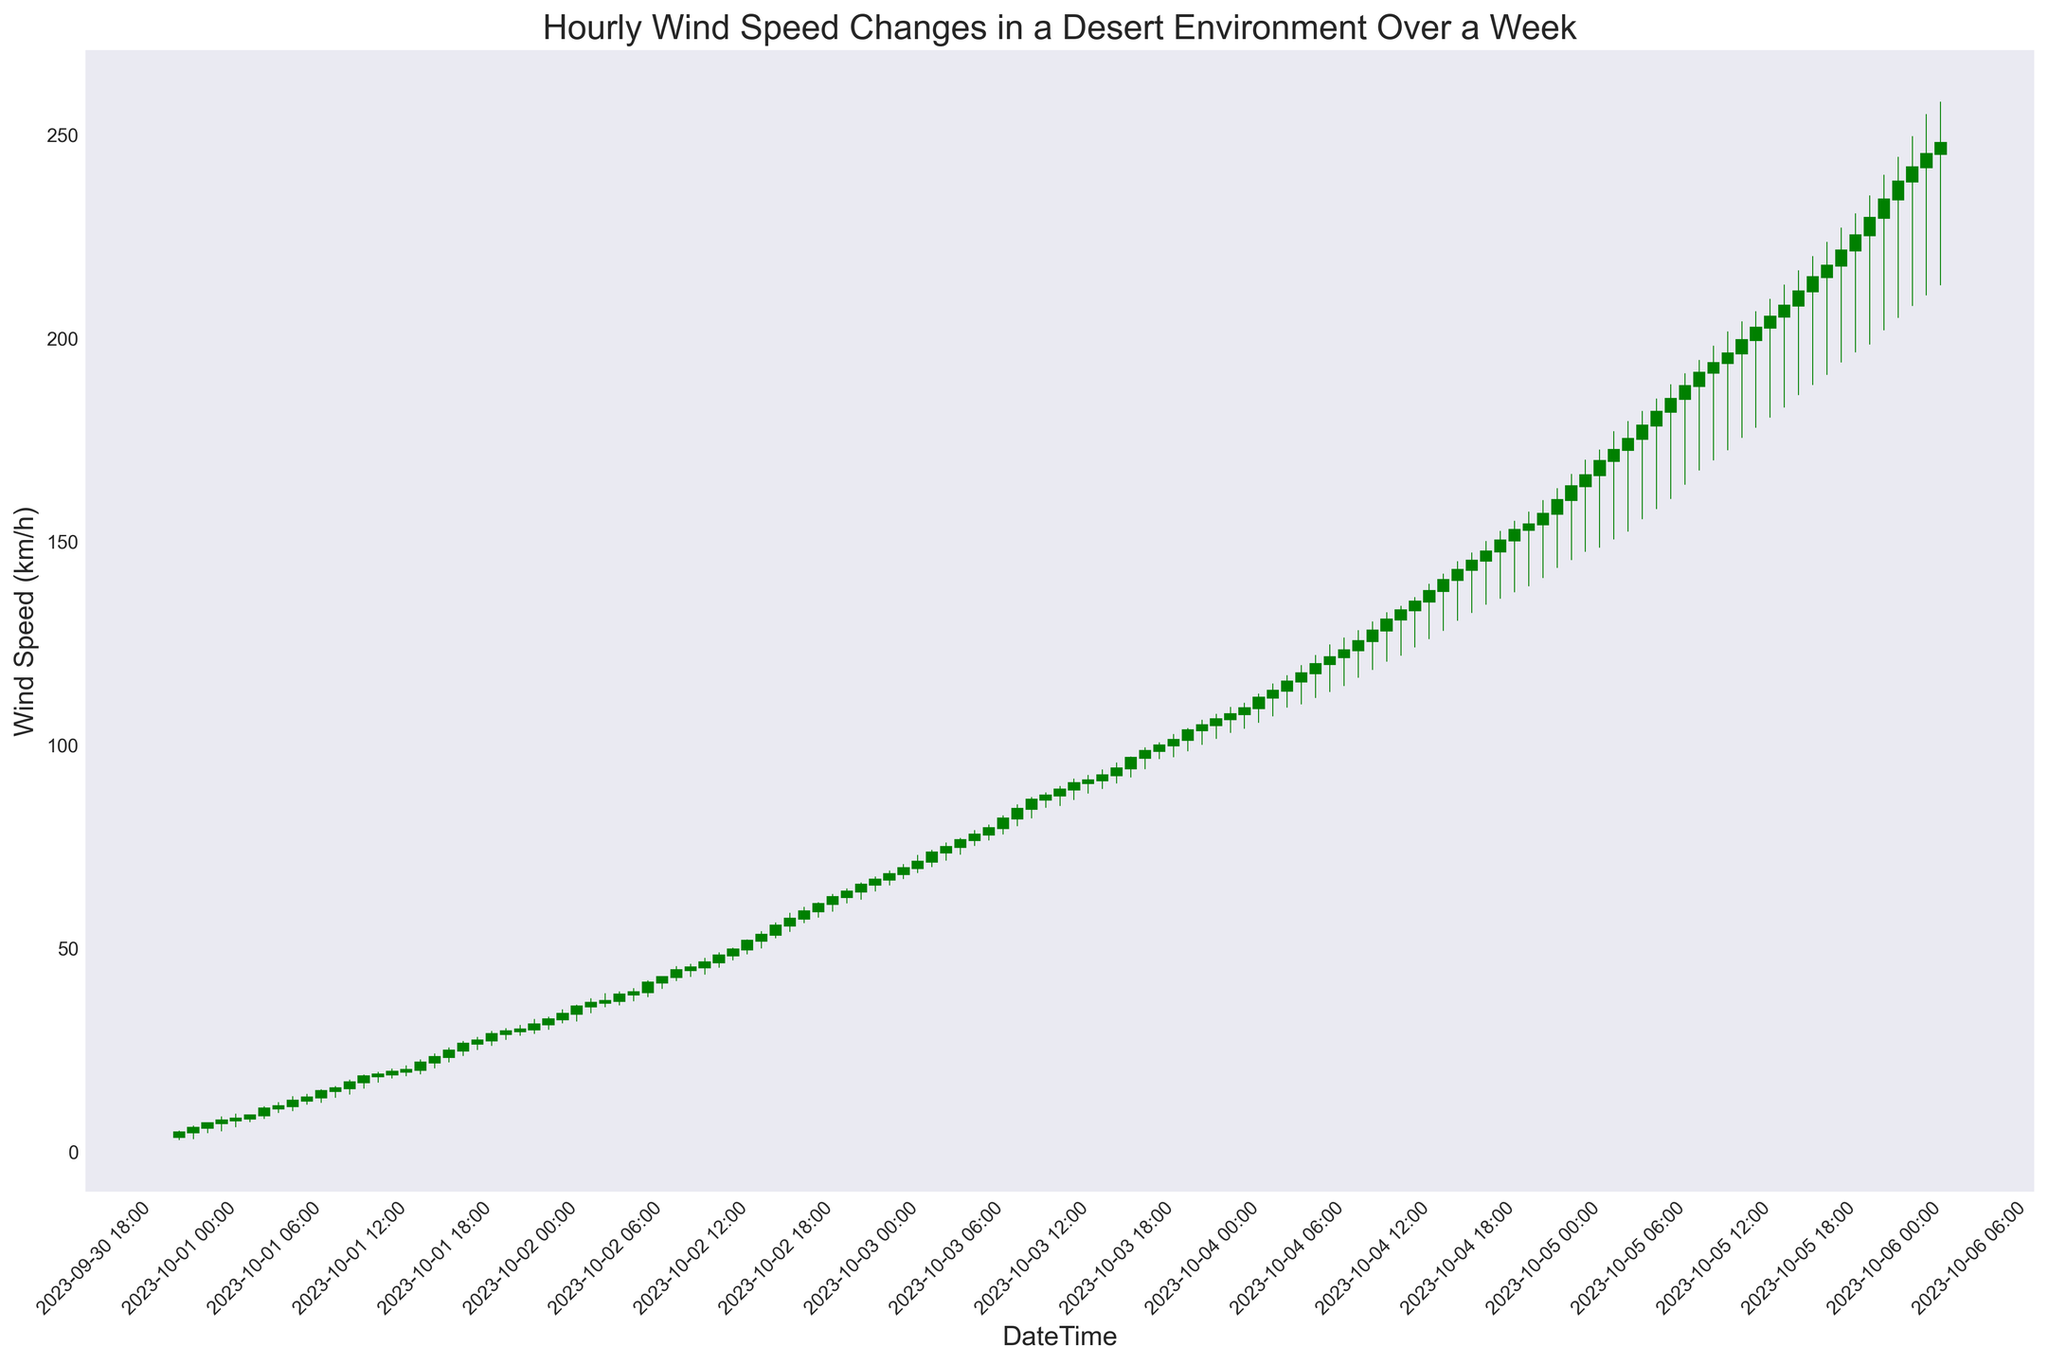What is the wind speed at 10 AM on October 1st? To find the wind speed at this specific time, locate the corresponding candlestick and look at the closing value. On the candlestick for October 1st at 10 AM, the closing value (top of the candlestick body) represents the wind speed.
Answer: 14.8 km/h What was the highest wind speed recorded on October 3rd? Identify all the candlesticks for October 3rd and check the highest point (the wick) of these candlesticks. The highest point represents the highest wind speed recorded.
Answer: 104.0 km/h Which hour experienced the steepest increase in wind speed within the first 24 hours? Compare the lengths of the green candlesticks within the first 24 hours. A longer green candlestick indicates a larger increase in wind speed. Find the one with the longest body among these candlesticks.
Answer: October 1st, 6 AM What is the average wind speed between 2 PM and 6 PM on October 4th? Identify the candlesticks between 2 PM and 6 PM on October 4th (14:00 to 18:00). Note the closing values of these: 133.0, 135.2, 137.8, 140.5, 143.0. Calculate their average by summing these values and dividing by the number of hours. (133.0 + 135.2 + 137.8 + 140.5 + 143.0) / 5.
Answer: 137.9 km/h How does the wind speed at midnight on October 2nd compare to the wind speed at noon on the same day? Compare the candlestick for October 2nd at 12 AM (midnight) and find the closing value, then compare it to the candlestick for October 2nd at 12 PM (noon). Look at their heights to see the difference visually.
Answer: 30.0 km/h at midnight, 45.2 km/h at noon Which day had the most consistent wind speed pattern, based on the candlestick lengths? Look for the day where the candlesticks have relatively similar heights and smaller wicks indicating consistency. This can be inferred by observing the uniformity in the lengths of the candlesticks across the day.
Answer: October 1st What is the difference in wind speed between the highest gust and the lowest trough for the week? Identify the highest high (the topmost point of the wicks) and the lowest low (the bottommost point of the wicks) from all candlesticks throughout the week. The highest high is 258.0 km/h and the lowest low is 2.8 km/h. Compute the difference: 258.0 - 2.8.
Answer: 255.2 km/h Was there more wind speed increase or decrease during the hour from 10 PM on October 1st to 11 PM on October 1st? Look at the candlestick for 10 PM to 11 PM on October 1st. If it is green, the wind speed increased; if it is red, it decreased. Specifically, compare the bottom of the body (open) to the top of the body (close).
Answer: Increase 